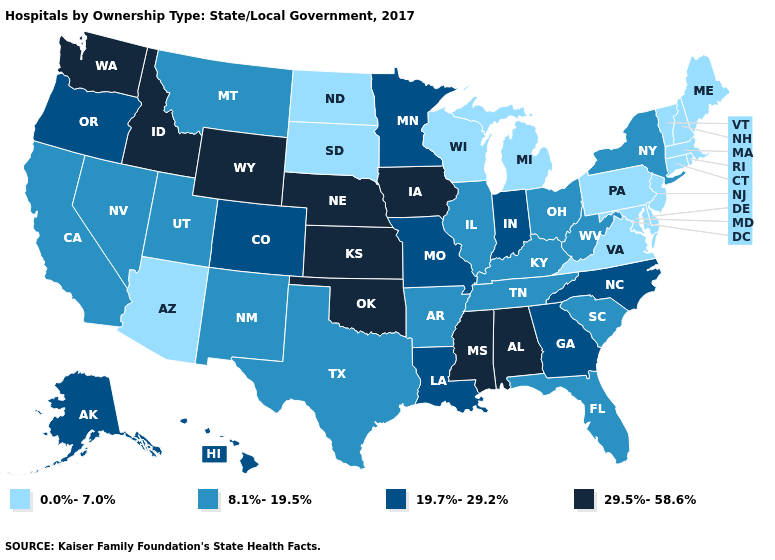What is the lowest value in states that border Mississippi?
Answer briefly. 8.1%-19.5%. Which states have the lowest value in the USA?
Short answer required. Arizona, Connecticut, Delaware, Maine, Maryland, Massachusetts, Michigan, New Hampshire, New Jersey, North Dakota, Pennsylvania, Rhode Island, South Dakota, Vermont, Virginia, Wisconsin. What is the highest value in states that border West Virginia?
Concise answer only. 8.1%-19.5%. Does Vermont have the lowest value in the USA?
Answer briefly. Yes. Does Virginia have the lowest value in the South?
Short answer required. Yes. What is the lowest value in states that border Virginia?
Write a very short answer. 0.0%-7.0%. Name the states that have a value in the range 19.7%-29.2%?
Concise answer only. Alaska, Colorado, Georgia, Hawaii, Indiana, Louisiana, Minnesota, Missouri, North Carolina, Oregon. Among the states that border Wisconsin , does Iowa have the highest value?
Answer briefly. Yes. Does Illinois have the lowest value in the MidWest?
Write a very short answer. No. Which states have the highest value in the USA?
Concise answer only. Alabama, Idaho, Iowa, Kansas, Mississippi, Nebraska, Oklahoma, Washington, Wyoming. What is the value of Nevada?
Quick response, please. 8.1%-19.5%. Which states have the lowest value in the USA?
Keep it brief. Arizona, Connecticut, Delaware, Maine, Maryland, Massachusetts, Michigan, New Hampshire, New Jersey, North Dakota, Pennsylvania, Rhode Island, South Dakota, Vermont, Virginia, Wisconsin. Name the states that have a value in the range 0.0%-7.0%?
Answer briefly. Arizona, Connecticut, Delaware, Maine, Maryland, Massachusetts, Michigan, New Hampshire, New Jersey, North Dakota, Pennsylvania, Rhode Island, South Dakota, Vermont, Virginia, Wisconsin. Does Massachusetts have a lower value than Illinois?
Quick response, please. Yes. What is the value of Kentucky?
Answer briefly. 8.1%-19.5%. 